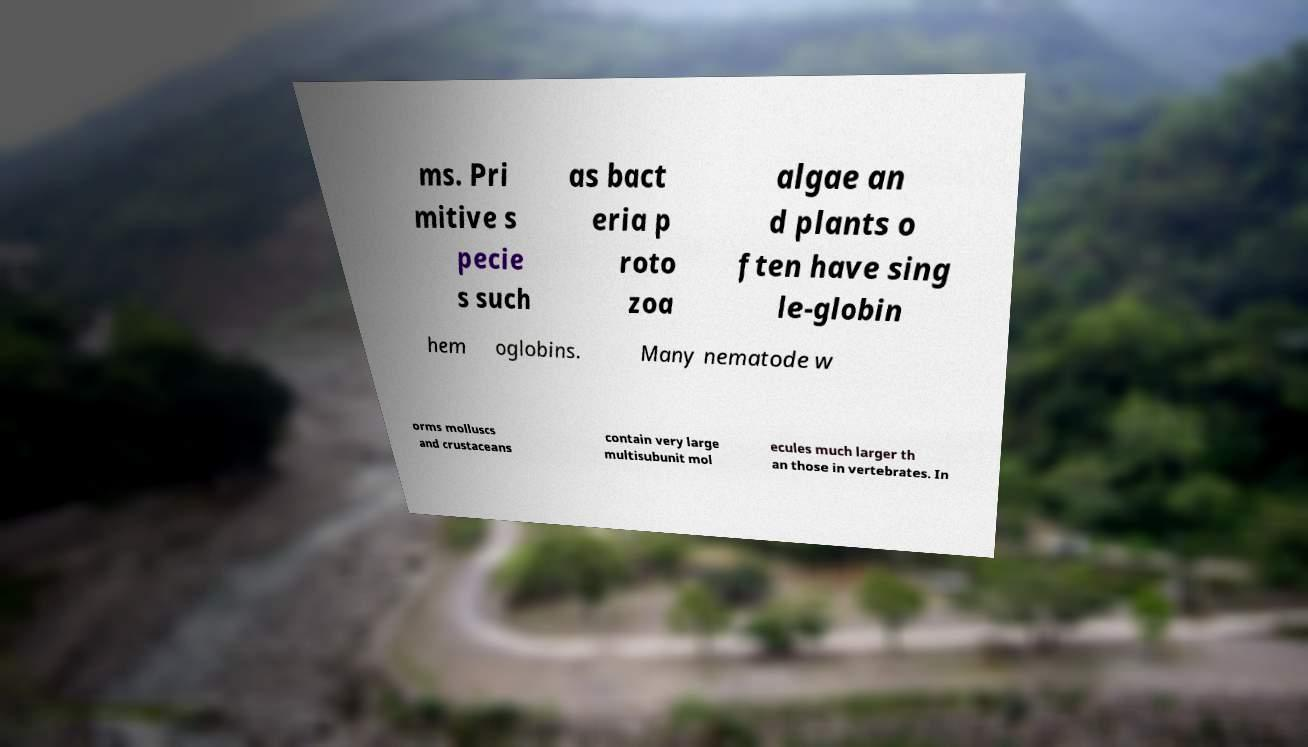What messages or text are displayed in this image? I need them in a readable, typed format. ms. Pri mitive s pecie s such as bact eria p roto zoa algae an d plants o ften have sing le-globin hem oglobins. Many nematode w orms molluscs and crustaceans contain very large multisubunit mol ecules much larger th an those in vertebrates. In 